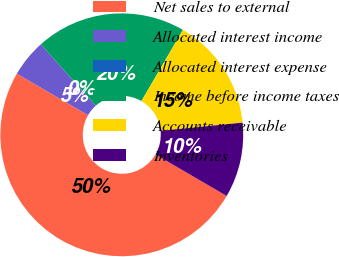Convert chart. <chart><loc_0><loc_0><loc_500><loc_500><pie_chart><fcel>Net sales to external<fcel>Allocated interest income<fcel>Allocated interest expense<fcel>Income before income taxes<fcel>Accounts receivable<fcel>Inventories<nl><fcel>49.99%<fcel>5.0%<fcel>0.0%<fcel>20.0%<fcel>15.0%<fcel>10.0%<nl></chart> 